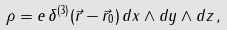<formula> <loc_0><loc_0><loc_500><loc_500>\rho = e \, \delta ^ { ( 3 ) } ( \vec { r } - \vec { r } _ { 0 } ) \, d x \wedge d y \wedge d z \, ,</formula> 